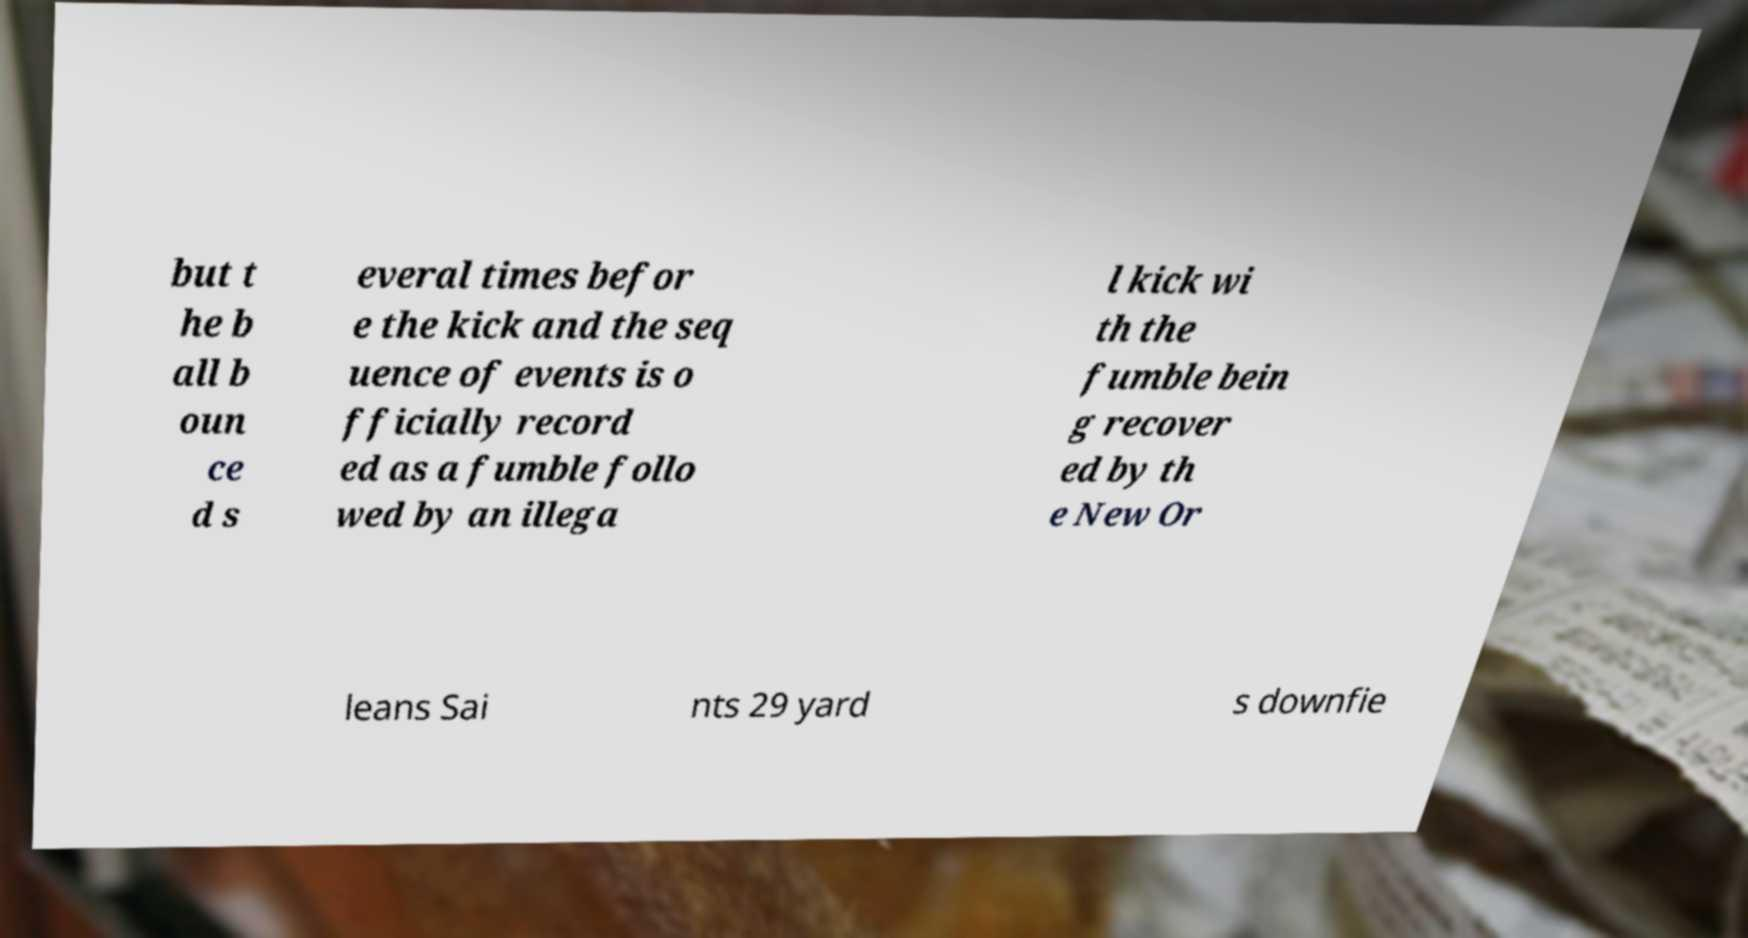What messages or text are displayed in this image? I need them in a readable, typed format. but t he b all b oun ce d s everal times befor e the kick and the seq uence of events is o fficially record ed as a fumble follo wed by an illega l kick wi th the fumble bein g recover ed by th e New Or leans Sai nts 29 yard s downfie 